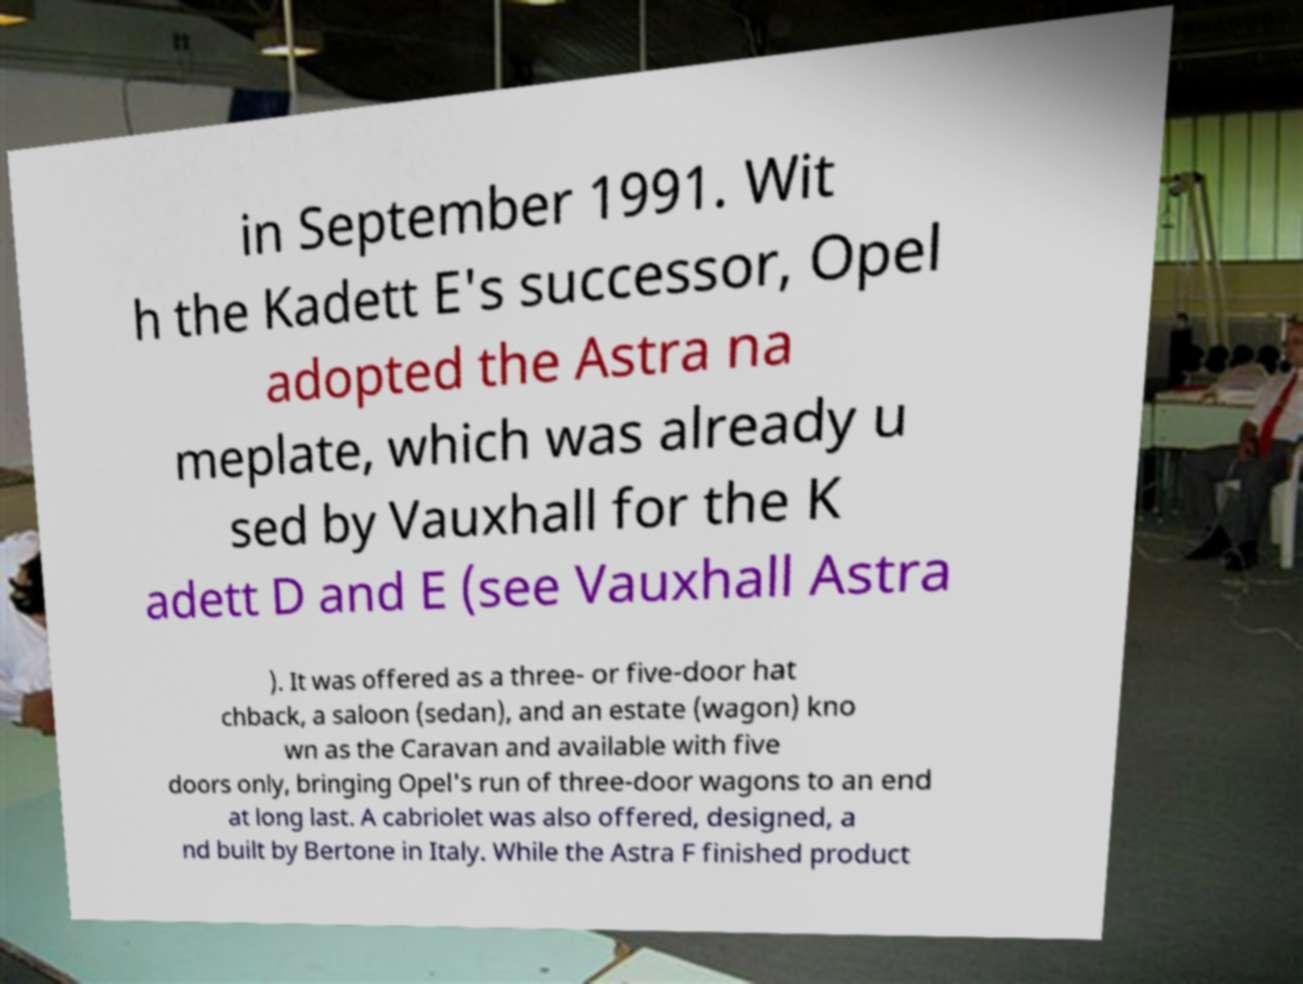There's text embedded in this image that I need extracted. Can you transcribe it verbatim? in September 1991. Wit h the Kadett E's successor, Opel adopted the Astra na meplate, which was already u sed by Vauxhall for the K adett D and E (see Vauxhall Astra ). It was offered as a three- or five-door hat chback, a saloon (sedan), and an estate (wagon) kno wn as the Caravan and available with five doors only, bringing Opel's run of three-door wagons to an end at long last. A cabriolet was also offered, designed, a nd built by Bertone in Italy. While the Astra F finished product 